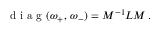<formula> <loc_0><loc_0><loc_500><loc_500>d i a g ( \omega _ { + } , \, \omega _ { - } ) = M ^ { - 1 } L M \, .</formula> 